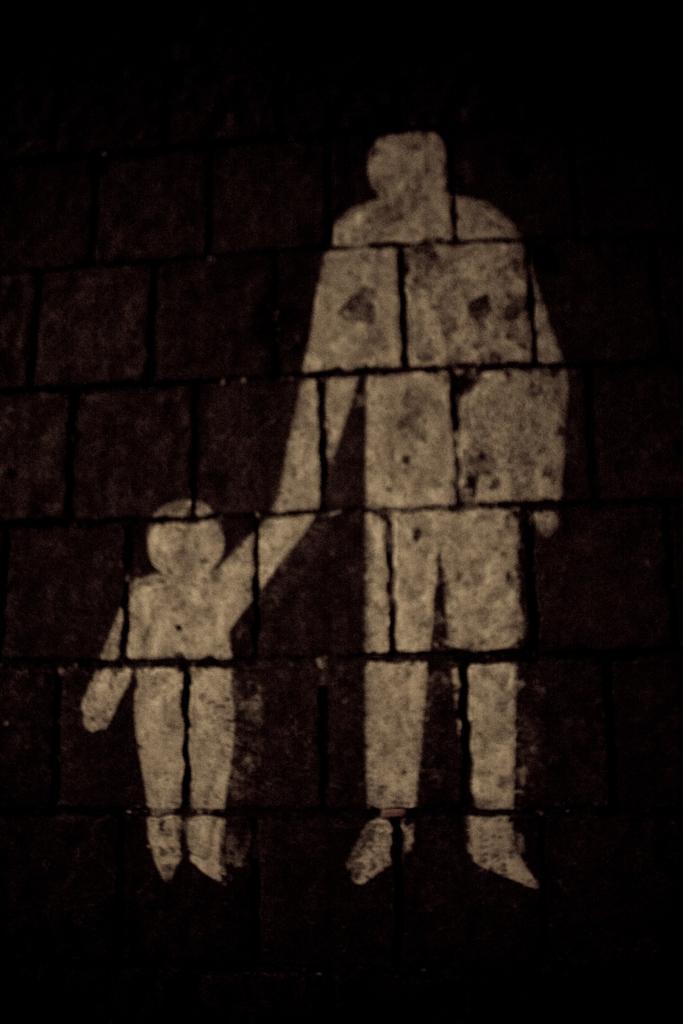Could you give a brief overview of what you see in this image? In this image, we can see painting on the wall. In the background, we can black color. 